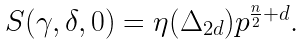Convert formula to latex. <formula><loc_0><loc_0><loc_500><loc_500>\begin{array} { c } S ( \gamma , \delta , 0 ) = \eta ( \Delta _ { 2 d } ) p ^ { \frac { n } { 2 } + d } . \end{array}</formula> 